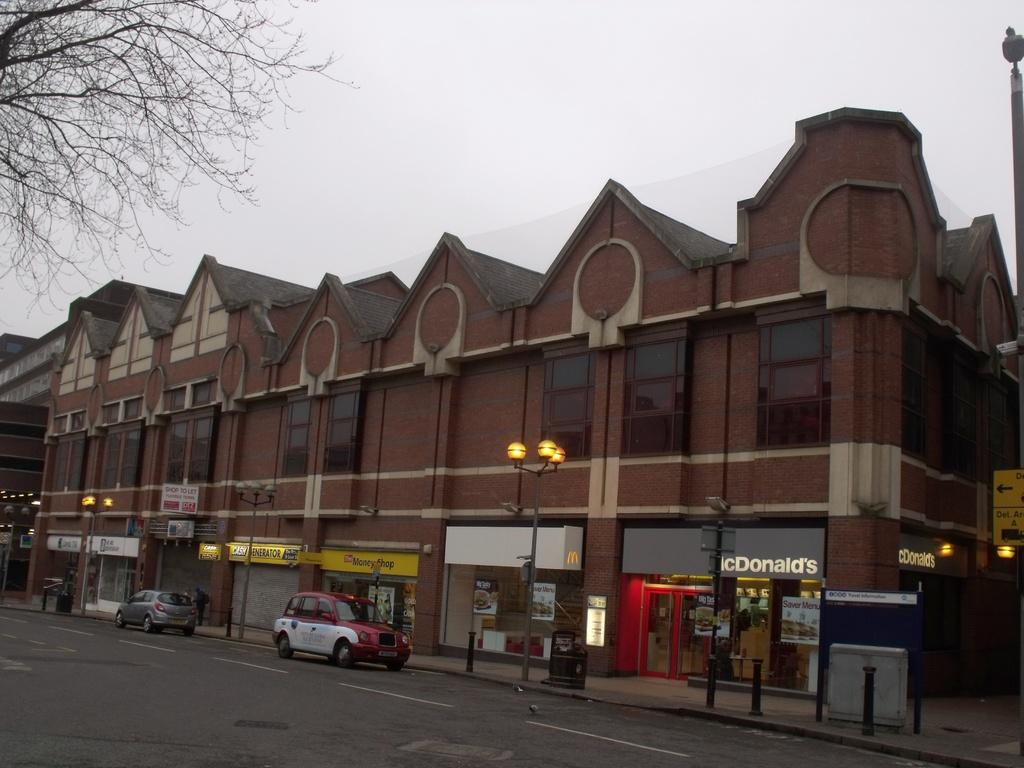Provide a one-sentence caption for the provided image. A brown building with multiple business, including a McDonald's. 